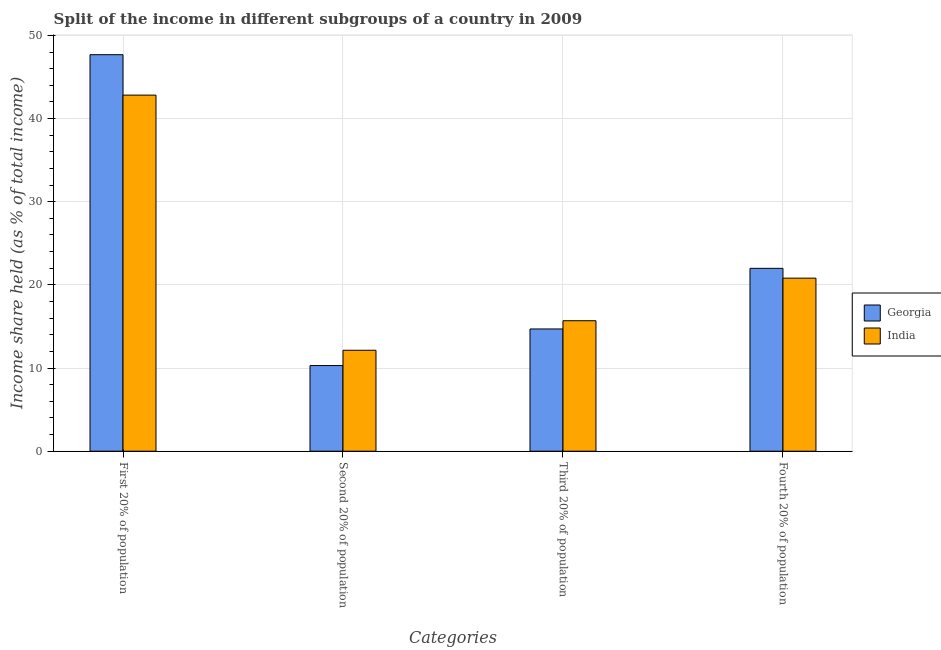How many different coloured bars are there?
Your answer should be compact. 2. How many bars are there on the 4th tick from the left?
Your response must be concise. 2. How many bars are there on the 3rd tick from the right?
Make the answer very short. 2. What is the label of the 1st group of bars from the left?
Give a very brief answer. First 20% of population. What is the share of the income held by second 20% of the population in India?
Ensure brevity in your answer.  12.14. Across all countries, what is the maximum share of the income held by fourth 20% of the population?
Offer a very short reply. 21.99. Across all countries, what is the minimum share of the income held by third 20% of the population?
Your answer should be compact. 14.7. In which country was the share of the income held by second 20% of the population minimum?
Provide a succinct answer. Georgia. What is the total share of the income held by first 20% of the population in the graph?
Your response must be concise. 90.5. What is the difference between the share of the income held by second 20% of the population in Georgia and that in India?
Your response must be concise. -1.84. What is the difference between the share of the income held by fourth 20% of the population in Georgia and the share of the income held by second 20% of the population in India?
Provide a short and direct response. 9.85. What is the average share of the income held by fourth 20% of the population per country?
Your answer should be very brief. 21.4. What is the difference between the share of the income held by second 20% of the population and share of the income held by third 20% of the population in Georgia?
Make the answer very short. -4.4. In how many countries, is the share of the income held by fourth 20% of the population greater than 32 %?
Give a very brief answer. 0. What is the ratio of the share of the income held by second 20% of the population in India to that in Georgia?
Make the answer very short. 1.18. Is the share of the income held by first 20% of the population in Georgia less than that in India?
Offer a terse response. No. What is the difference between the highest and the second highest share of the income held by second 20% of the population?
Ensure brevity in your answer.  1.84. What is the difference between the highest and the lowest share of the income held by second 20% of the population?
Provide a short and direct response. 1.84. Is the sum of the share of the income held by third 20% of the population in India and Georgia greater than the maximum share of the income held by first 20% of the population across all countries?
Offer a terse response. No. Is it the case that in every country, the sum of the share of the income held by third 20% of the population and share of the income held by second 20% of the population is greater than the sum of share of the income held by first 20% of the population and share of the income held by fourth 20% of the population?
Offer a very short reply. Yes. What does the 2nd bar from the right in First 20% of population represents?
Keep it short and to the point. Georgia. Is it the case that in every country, the sum of the share of the income held by first 20% of the population and share of the income held by second 20% of the population is greater than the share of the income held by third 20% of the population?
Offer a very short reply. Yes. How many bars are there?
Your answer should be compact. 8. Are all the bars in the graph horizontal?
Provide a short and direct response. No. Are the values on the major ticks of Y-axis written in scientific E-notation?
Offer a very short reply. No. Does the graph contain grids?
Offer a terse response. Yes. How many legend labels are there?
Offer a terse response. 2. How are the legend labels stacked?
Make the answer very short. Vertical. What is the title of the graph?
Keep it short and to the point. Split of the income in different subgroups of a country in 2009. Does "Middle East & North Africa (all income levels)" appear as one of the legend labels in the graph?
Provide a succinct answer. No. What is the label or title of the X-axis?
Make the answer very short. Categories. What is the label or title of the Y-axis?
Your response must be concise. Income share held (as % of total income). What is the Income share held (as % of total income) in Georgia in First 20% of population?
Your answer should be compact. 47.68. What is the Income share held (as % of total income) of India in First 20% of population?
Your answer should be very brief. 42.82. What is the Income share held (as % of total income) of India in Second 20% of population?
Offer a terse response. 12.14. What is the Income share held (as % of total income) in India in Third 20% of population?
Your answer should be very brief. 15.69. What is the Income share held (as % of total income) in Georgia in Fourth 20% of population?
Your answer should be very brief. 21.99. What is the Income share held (as % of total income) of India in Fourth 20% of population?
Offer a very short reply. 20.81. Across all Categories, what is the maximum Income share held (as % of total income) of Georgia?
Offer a terse response. 47.68. Across all Categories, what is the maximum Income share held (as % of total income) of India?
Provide a short and direct response. 42.82. Across all Categories, what is the minimum Income share held (as % of total income) in Georgia?
Make the answer very short. 10.3. Across all Categories, what is the minimum Income share held (as % of total income) in India?
Offer a terse response. 12.14. What is the total Income share held (as % of total income) in Georgia in the graph?
Your answer should be very brief. 94.67. What is the total Income share held (as % of total income) in India in the graph?
Offer a terse response. 91.46. What is the difference between the Income share held (as % of total income) in Georgia in First 20% of population and that in Second 20% of population?
Make the answer very short. 37.38. What is the difference between the Income share held (as % of total income) of India in First 20% of population and that in Second 20% of population?
Provide a short and direct response. 30.68. What is the difference between the Income share held (as % of total income) of Georgia in First 20% of population and that in Third 20% of population?
Offer a terse response. 32.98. What is the difference between the Income share held (as % of total income) in India in First 20% of population and that in Third 20% of population?
Offer a terse response. 27.13. What is the difference between the Income share held (as % of total income) of Georgia in First 20% of population and that in Fourth 20% of population?
Provide a succinct answer. 25.69. What is the difference between the Income share held (as % of total income) of India in First 20% of population and that in Fourth 20% of population?
Ensure brevity in your answer.  22.01. What is the difference between the Income share held (as % of total income) of India in Second 20% of population and that in Third 20% of population?
Your response must be concise. -3.55. What is the difference between the Income share held (as % of total income) of Georgia in Second 20% of population and that in Fourth 20% of population?
Provide a short and direct response. -11.69. What is the difference between the Income share held (as % of total income) of India in Second 20% of population and that in Fourth 20% of population?
Give a very brief answer. -8.67. What is the difference between the Income share held (as % of total income) of Georgia in Third 20% of population and that in Fourth 20% of population?
Offer a very short reply. -7.29. What is the difference between the Income share held (as % of total income) in India in Third 20% of population and that in Fourth 20% of population?
Ensure brevity in your answer.  -5.12. What is the difference between the Income share held (as % of total income) in Georgia in First 20% of population and the Income share held (as % of total income) in India in Second 20% of population?
Offer a terse response. 35.54. What is the difference between the Income share held (as % of total income) of Georgia in First 20% of population and the Income share held (as % of total income) of India in Third 20% of population?
Your answer should be compact. 31.99. What is the difference between the Income share held (as % of total income) in Georgia in First 20% of population and the Income share held (as % of total income) in India in Fourth 20% of population?
Provide a short and direct response. 26.87. What is the difference between the Income share held (as % of total income) of Georgia in Second 20% of population and the Income share held (as % of total income) of India in Third 20% of population?
Provide a short and direct response. -5.39. What is the difference between the Income share held (as % of total income) in Georgia in Second 20% of population and the Income share held (as % of total income) in India in Fourth 20% of population?
Ensure brevity in your answer.  -10.51. What is the difference between the Income share held (as % of total income) in Georgia in Third 20% of population and the Income share held (as % of total income) in India in Fourth 20% of population?
Offer a terse response. -6.11. What is the average Income share held (as % of total income) in Georgia per Categories?
Offer a terse response. 23.67. What is the average Income share held (as % of total income) in India per Categories?
Keep it short and to the point. 22.86. What is the difference between the Income share held (as % of total income) of Georgia and Income share held (as % of total income) of India in First 20% of population?
Keep it short and to the point. 4.86. What is the difference between the Income share held (as % of total income) of Georgia and Income share held (as % of total income) of India in Second 20% of population?
Your answer should be compact. -1.84. What is the difference between the Income share held (as % of total income) in Georgia and Income share held (as % of total income) in India in Third 20% of population?
Make the answer very short. -0.99. What is the difference between the Income share held (as % of total income) in Georgia and Income share held (as % of total income) in India in Fourth 20% of population?
Ensure brevity in your answer.  1.18. What is the ratio of the Income share held (as % of total income) of Georgia in First 20% of population to that in Second 20% of population?
Keep it short and to the point. 4.63. What is the ratio of the Income share held (as % of total income) of India in First 20% of population to that in Second 20% of population?
Your response must be concise. 3.53. What is the ratio of the Income share held (as % of total income) in Georgia in First 20% of population to that in Third 20% of population?
Your answer should be very brief. 3.24. What is the ratio of the Income share held (as % of total income) in India in First 20% of population to that in Third 20% of population?
Your response must be concise. 2.73. What is the ratio of the Income share held (as % of total income) in Georgia in First 20% of population to that in Fourth 20% of population?
Offer a very short reply. 2.17. What is the ratio of the Income share held (as % of total income) of India in First 20% of population to that in Fourth 20% of population?
Make the answer very short. 2.06. What is the ratio of the Income share held (as % of total income) in Georgia in Second 20% of population to that in Third 20% of population?
Ensure brevity in your answer.  0.7. What is the ratio of the Income share held (as % of total income) in India in Second 20% of population to that in Third 20% of population?
Give a very brief answer. 0.77. What is the ratio of the Income share held (as % of total income) in Georgia in Second 20% of population to that in Fourth 20% of population?
Keep it short and to the point. 0.47. What is the ratio of the Income share held (as % of total income) of India in Second 20% of population to that in Fourth 20% of population?
Your response must be concise. 0.58. What is the ratio of the Income share held (as % of total income) in Georgia in Third 20% of population to that in Fourth 20% of population?
Your response must be concise. 0.67. What is the ratio of the Income share held (as % of total income) in India in Third 20% of population to that in Fourth 20% of population?
Give a very brief answer. 0.75. What is the difference between the highest and the second highest Income share held (as % of total income) of Georgia?
Ensure brevity in your answer.  25.69. What is the difference between the highest and the second highest Income share held (as % of total income) in India?
Give a very brief answer. 22.01. What is the difference between the highest and the lowest Income share held (as % of total income) of Georgia?
Keep it short and to the point. 37.38. What is the difference between the highest and the lowest Income share held (as % of total income) of India?
Make the answer very short. 30.68. 